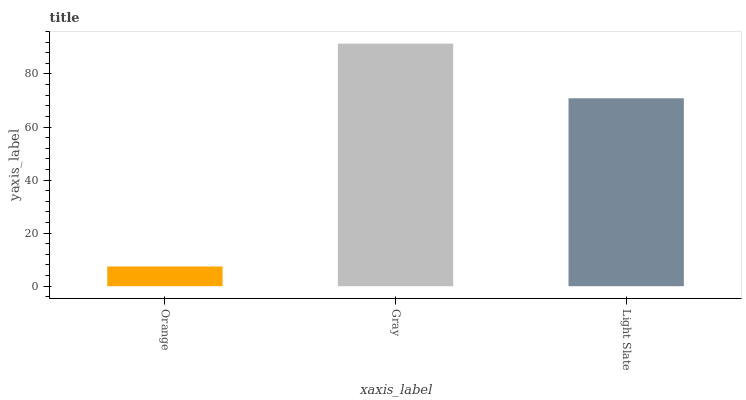Is Orange the minimum?
Answer yes or no. Yes. Is Gray the maximum?
Answer yes or no. Yes. Is Light Slate the minimum?
Answer yes or no. No. Is Light Slate the maximum?
Answer yes or no. No. Is Gray greater than Light Slate?
Answer yes or no. Yes. Is Light Slate less than Gray?
Answer yes or no. Yes. Is Light Slate greater than Gray?
Answer yes or no. No. Is Gray less than Light Slate?
Answer yes or no. No. Is Light Slate the high median?
Answer yes or no. Yes. Is Light Slate the low median?
Answer yes or no. Yes. Is Gray the high median?
Answer yes or no. No. Is Orange the low median?
Answer yes or no. No. 